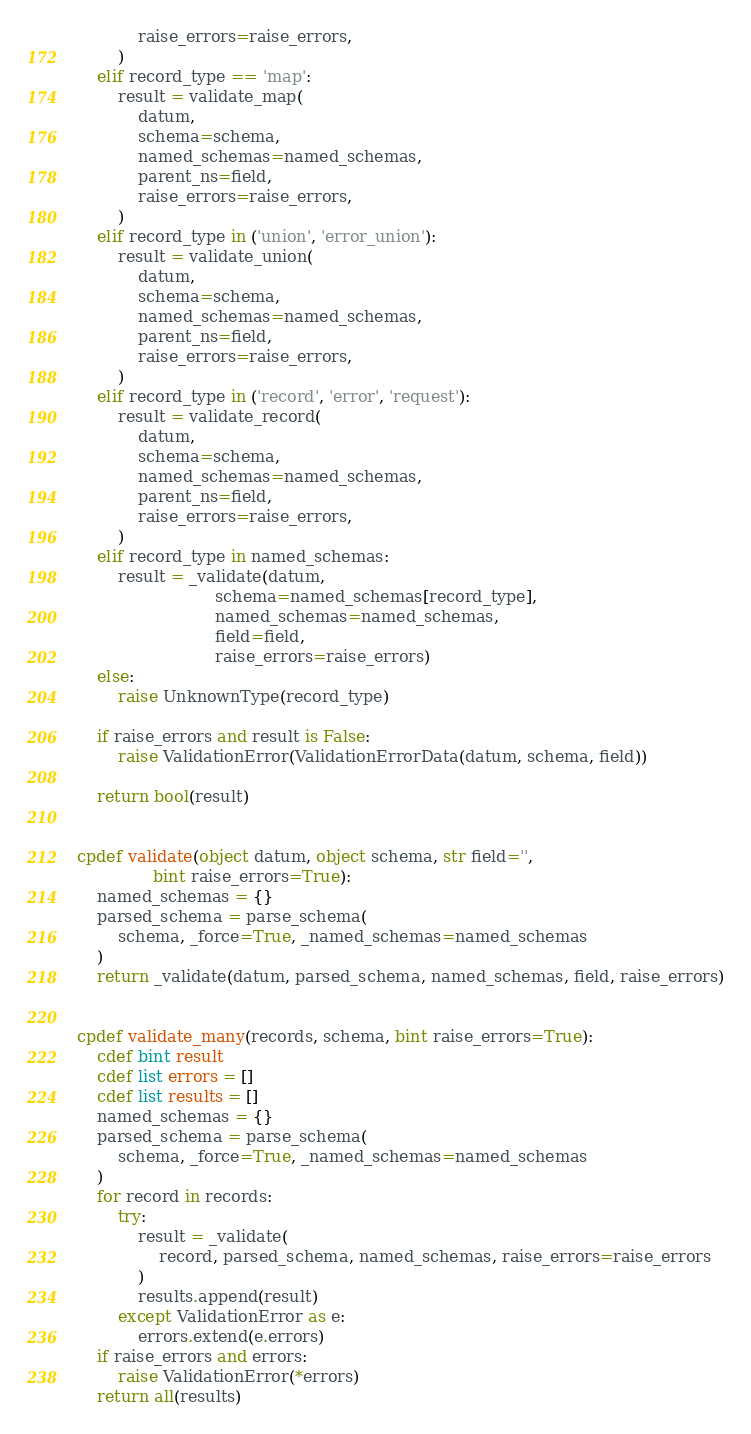<code> <loc_0><loc_0><loc_500><loc_500><_Cython_>            raise_errors=raise_errors,
        )
    elif record_type == 'map':
        result = validate_map(
            datum,
            schema=schema,
            named_schemas=named_schemas,
            parent_ns=field,
            raise_errors=raise_errors,
        )
    elif record_type in ('union', 'error_union'):
        result = validate_union(
            datum,
            schema=schema,
            named_schemas=named_schemas,
            parent_ns=field,
            raise_errors=raise_errors,
        )
    elif record_type in ('record', 'error', 'request'):
        result = validate_record(
            datum,
            schema=schema,
            named_schemas=named_schemas,
            parent_ns=field,
            raise_errors=raise_errors,
        )
    elif record_type in named_schemas:
        result = _validate(datum,
                           schema=named_schemas[record_type],
                           named_schemas=named_schemas,
                           field=field,
                           raise_errors=raise_errors)
    else:
        raise UnknownType(record_type)

    if raise_errors and result is False:
        raise ValidationError(ValidationErrorData(datum, schema, field))

    return bool(result)


cpdef validate(object datum, object schema, str field='',
               bint raise_errors=True):
    named_schemas = {}
    parsed_schema = parse_schema(
        schema, _force=True, _named_schemas=named_schemas
    )
    return _validate(datum, parsed_schema, named_schemas, field, raise_errors)


cpdef validate_many(records, schema, bint raise_errors=True):
    cdef bint result
    cdef list errors = []
    cdef list results = []
    named_schemas = {}
    parsed_schema = parse_schema(
        schema, _force=True, _named_schemas=named_schemas
    )
    for record in records:
        try:
            result = _validate(
                record, parsed_schema, named_schemas, raise_errors=raise_errors
            )
            results.append(result)
        except ValidationError as e:
            errors.extend(e.errors)
    if raise_errors and errors:
        raise ValidationError(*errors)
    return all(results)
</code> 